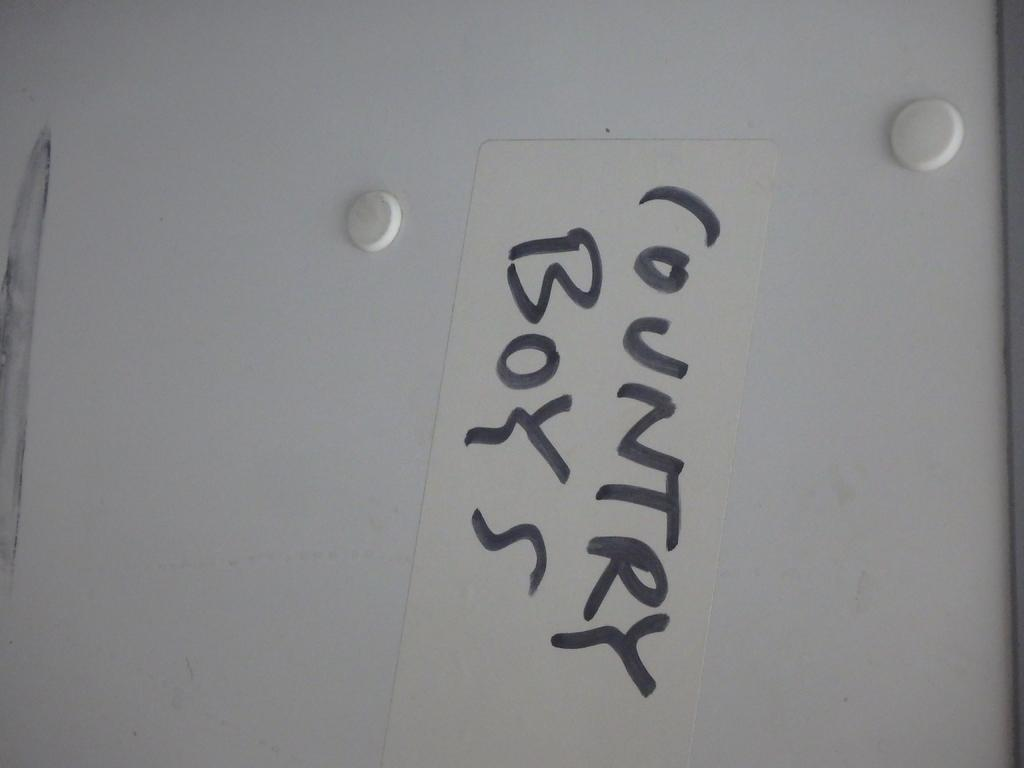What is the primary object in the image? There is a white color board in the image. What is written on the color board? There is black text on the board. How many birds are sitting on the rake in the image? There are no birds or rakes present in the image; it only features a white color board with black text. 